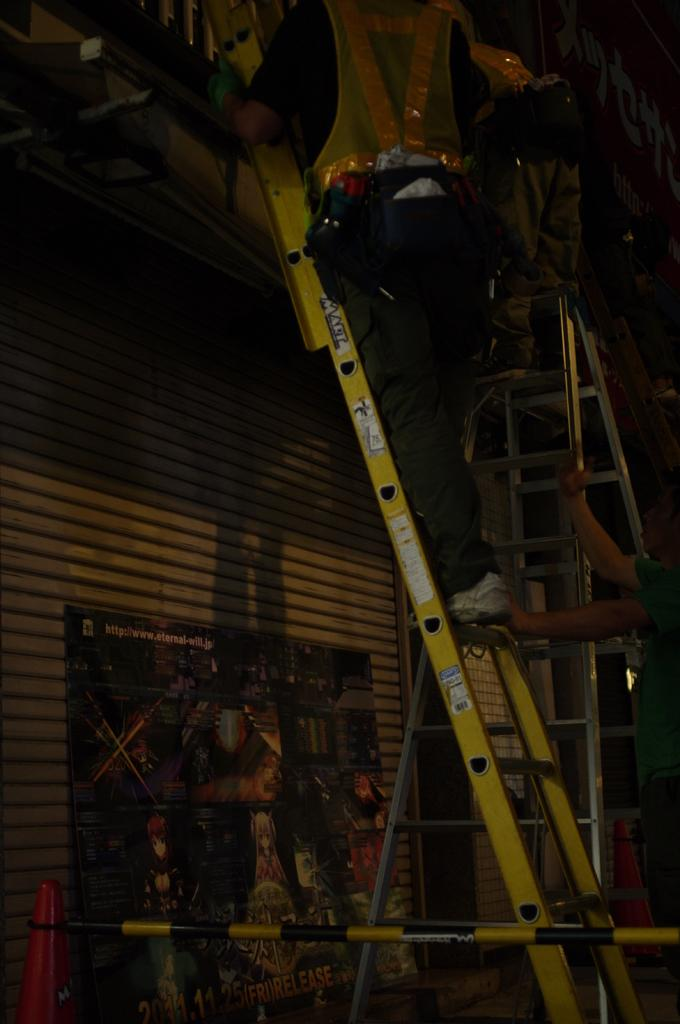What is the man in the image doing? The man is climbing a ladder in the image. Who is assisting the man climbing the ladder? There is another person holding the ladder in the image. What can be seen below the ladder? There is an advertisement visible below the ladder, and a traffic cone is present below the ladder. What is the iron pole in the image used for? The purpose of the iron pole in the image is not specified, but it could be used for support or as part of a structure. How many cans of paint are being used by the cows in the image? There are no cows or paint cans present in the image. 